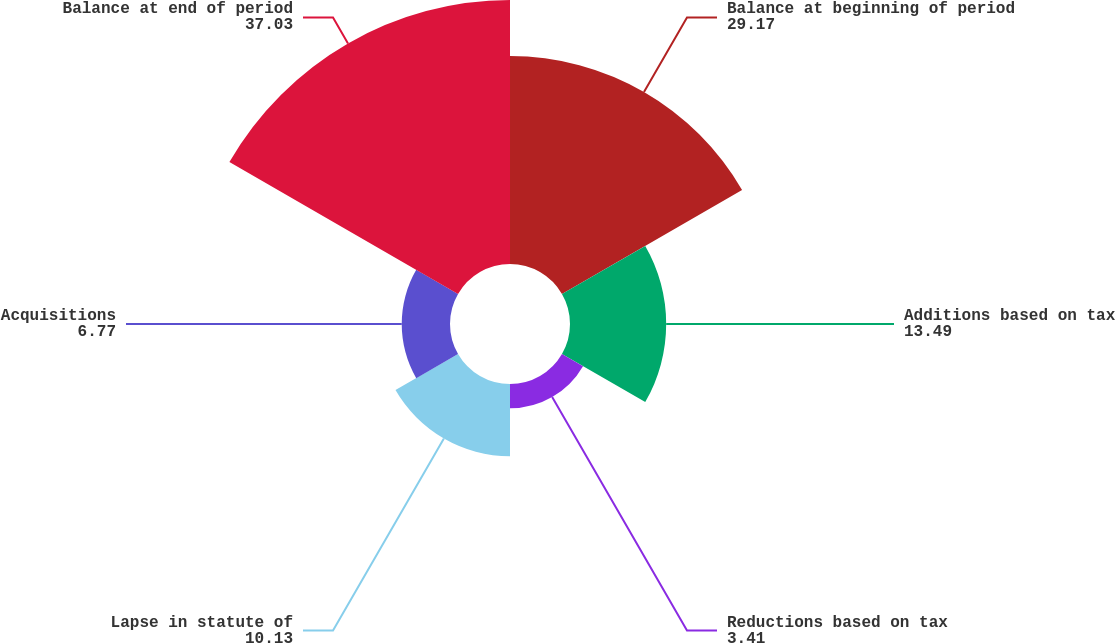Convert chart to OTSL. <chart><loc_0><loc_0><loc_500><loc_500><pie_chart><fcel>Balance at beginning of period<fcel>Additions based on tax<fcel>Reductions based on tax<fcel>Lapse in statute of<fcel>Acquisitions<fcel>Balance at end of period<nl><fcel>29.17%<fcel>13.49%<fcel>3.41%<fcel>10.13%<fcel>6.77%<fcel>37.03%<nl></chart> 